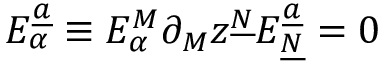<formula> <loc_0><loc_0><loc_500><loc_500>E _ { \alpha } ^ { \underline { a } } \equiv E _ { \alpha } ^ { M } \partial _ { M } z ^ { \underline { N } } E _ { \underline { N } } ^ { \underline { a } } = 0</formula> 